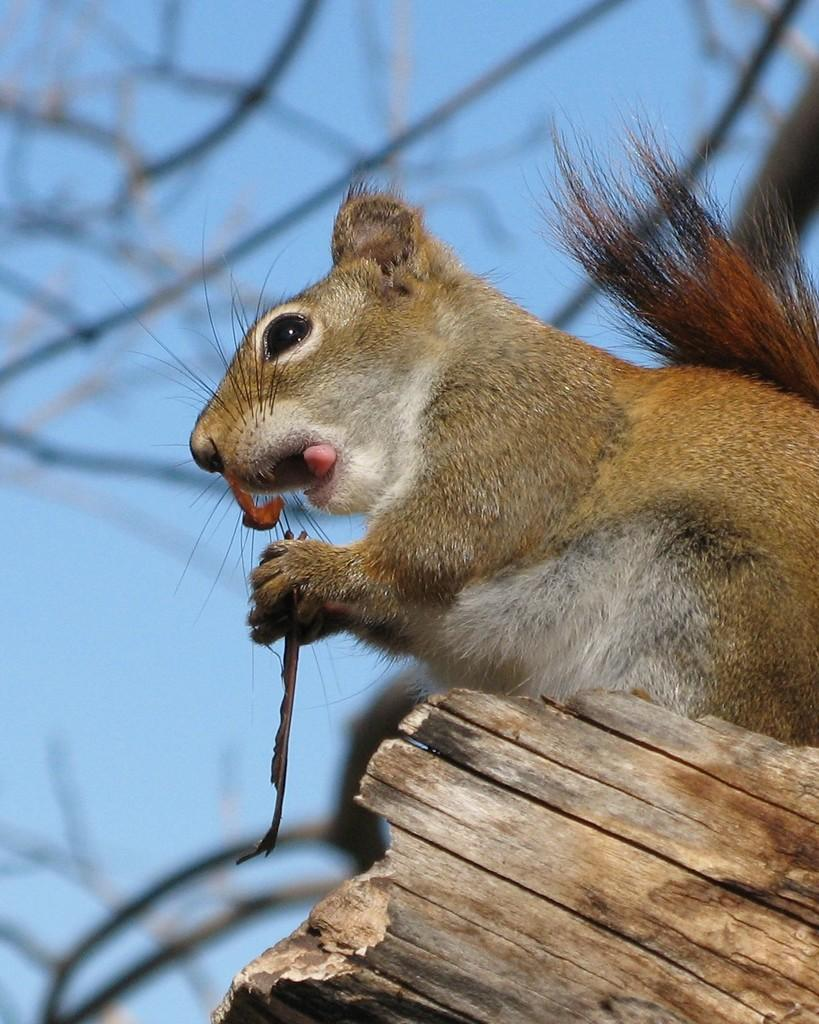What animal is present in the image? There is a squirrel in the image. What is the squirrel holding in the image? The squirrel is holding an object. What can be seen at the bottom of the image? There is a wooden stick at the bottom of the image. What is the condition of the background in the image? The background of the image is blurry. What type of vegetation is visible in the background? There are stems visible in the background. What part of the natural environment is visible in the background? The sky is visible in the background. What type of drink is the squirrel holding in the image? There is no drink present in the image; the squirrel is holding an object. What color is the crayon in the image? There is no crayon present in the image. 